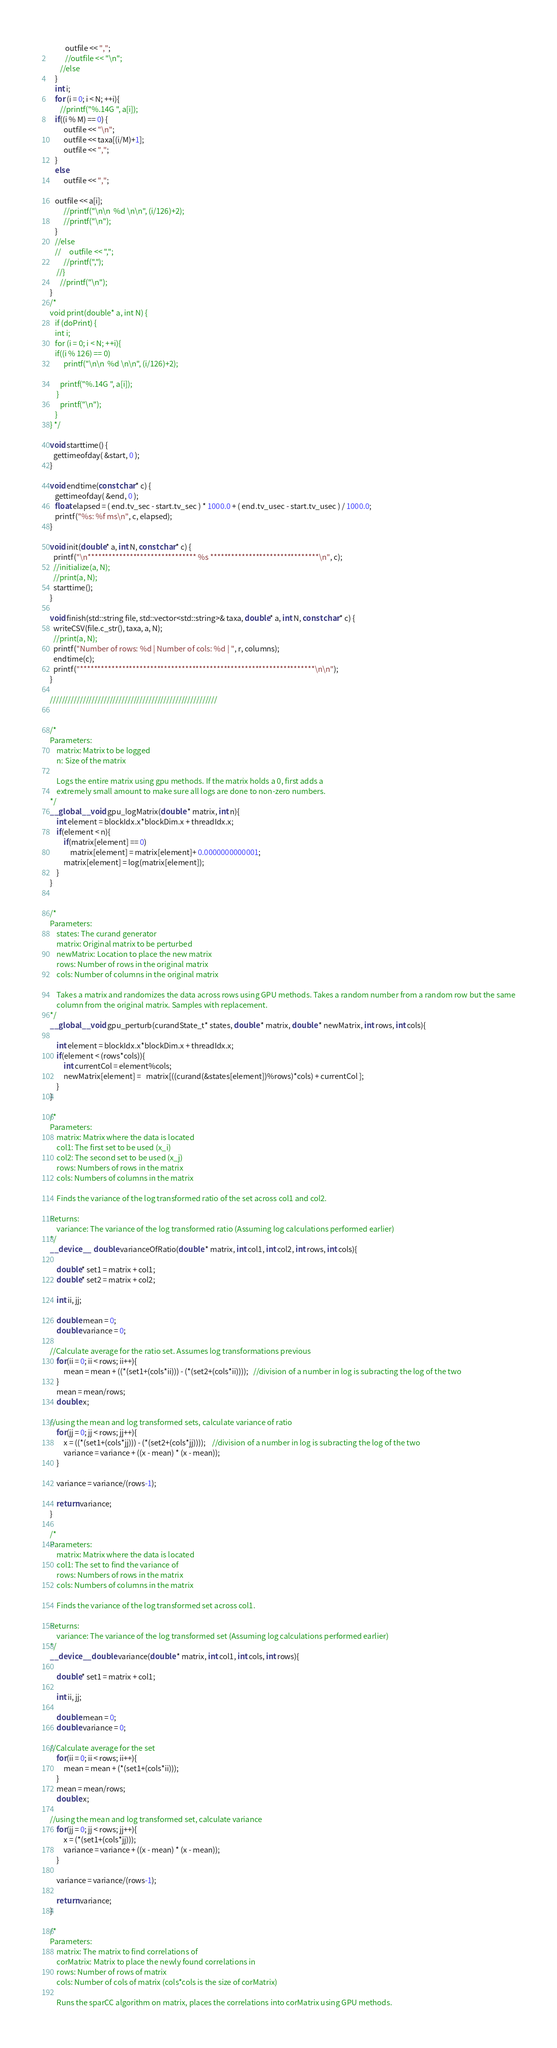<code> <loc_0><loc_0><loc_500><loc_500><_Cuda_>         outfile << ",";
         //outfile << "\n";
      //else
   }
   int i;
   for (i = 0; i < N; ++i){
      //printf("%.14G ", a[i]);
   if((i % M) == 0) {
        outfile << "\n";
        outfile << taxa[(i/M)+1];
        outfile << ",";
   }
   else
        outfile << ",";

   outfile << a[i];
        //printf("\n\n  %d \n\n", (i/126)+2);
        //printf("\n");
   }
   //else
   //     outfile << ",";
        //printf(",");
    //}
      //printf("\n");
}
/*
void print(double* a, int N) {
   if (doPrint) {
   int i;
   for (i = 0; i < N; ++i){
   if((i % 126) == 0)
        printf("\n\n  %d \n\n", (i/126)+2);
        
      printf("%.14G ", a[i]);
    }
      printf("\n");
   }
} */ 

void starttime() {
  gettimeofday( &start, 0 );
}

void endtime(const char* c) {
   gettimeofday( &end, 0 );
   float elapsed = ( end.tv_sec - start.tv_sec ) * 1000.0 + ( end.tv_usec - start.tv_usec ) / 1000.0;
   printf("%s: %f ms\n", c, elapsed); 
}

void init(double* a, int N, const char* c) {
  printf("\n******************************* %s *******************************\n", c);
  //initialize(a, N); 
  //print(a, N);
  starttime();
}

void finish(std::string file, std::vector<std::string>& taxa, double* a, int N, const char* c) {
  writeCSV(file.c_str(), taxa, a, N);
  //print(a, N);
  printf("Number of rows: %d | Number of cols: %d | ", r, columns);
  endtime(c);
  printf("*******************************************************************\n\n");
}

////////////////////////////////////////////////////////


/*
Parameters: 
    matrix: Matrix to be logged
    n: Size of the matrix
    
    Logs the entire matrix using gpu methods. If the matrix holds a 0, first adds a
    extremely small amount to make sure all logs are done to non-zero numbers.
*/
__global__ void gpu_logMatrix(double * matrix, int n){   
    int element = blockIdx.x*blockDim.x + threadIdx.x;
    if(element < n){
        if(matrix[element] == 0)
            matrix[element] = matrix[element]+ 0.0000000000001;
        matrix[element] = log(matrix[element]);    
    }
}


/*
Parameters:
    states: The curand generator
    matrix: Original matrix to be perturbed
    newMatrix: Location to place the new matrix
    rows: Number of rows in the original matrix
    cols: Number of columns in the original matrix
    
    Takes a matrix and randomizes the data across rows using GPU methods. Takes a random number from a random row but the same
    column from the original matrix. Samples with replacement.
*/
__global__ void gpu_perturb(curandState_t* states, double * matrix, double * newMatrix, int rows, int cols){
    
    int element = blockIdx.x*blockDim.x + threadIdx.x;
    if(element < (rows*cols)){        
        int currentCol = element%cols;       
        newMatrix[element] =   matrix[((curand(&states[element])%rows)*cols) + currentCol ];      
    } 
}

/*
Parameters:
    matrix: Matrix where the data is located
    col1: The first set to be used (x_i)
    col2: The second set to be used (x_j)
    rows: Numbers of rows in the matrix
    cols: Numbers of columns in the matrix
    
    Finds the variance of the log transformed ratio of the set across col1 and col2. 
    
Returns:
    variance: The variance of the log transformed ratio (Assuming log calculations performed earlier)
*/
__device__  double varianceOfRatio(double * matrix, int col1, int col2, int rows, int cols){
    
    double* set1 = matrix + col1;
    double* set2 = matrix + col2;
    
    int ii, jj;
    
    double mean = 0; 
    double variance = 0;

//Calculate average for the ratio set. Assumes log transformations previous
    for(ii = 0; ii < rows; ii++){
        mean = mean + ((*(set1+(cols*ii))) - (*(set2+(cols*ii))));   //division of a number in log is subracting the log of the two             
    }
    mean = mean/rows;
    double x;
    
//using the mean and log transformed sets, calculate variance of ratio
    for(jj = 0; jj < rows; jj++){
        x = ((*(set1+(cols*jj))) - (*(set2+(cols*jj))));    //division of a number in log is subracting the log of the two 
        variance = variance + ((x - mean) * (x - mean));                
    }
    
    variance = variance/(rows-1);
    
    return variance;
}

/*
Parameters:
    matrix: Matrix where the data is located
    col1: The set to find the variance of
    rows: Numbers of rows in the matrix
    cols: Numbers of columns in the matrix
    
    Finds the variance of the log transformed set across col1. 
    
Returns:
    variance: The variance of the log transformed set (Assuming log calculations performed earlier)
*/
__device__ double variance(double * matrix, int col1, int cols, int rows){
    
    double* set1 = matrix + col1;
    
    int ii, jj;
    
    double mean = 0; 
    double variance = 0;
    
//Calculate average for the set
    for(ii = 0; ii < rows; ii++){
        mean = mean + (*(set1+(cols*ii)));                
    }
    mean = mean/rows;
    double x;
    
//using the mean and log transformed set, calculate variance
    for(jj = 0; jj < rows; jj++){
        x = (*(set1+(cols*jj)));
        variance = variance + ((x - mean) * (x - mean));                
    }
    
    variance = variance/(rows-1);
    
    return variance;
}

/*
Parameters:
    matrix: The matrix to find correlations of
    corMatrix: Matrix to place the newly found correlations in
    rows: Number of rows of matrix
    cols: Number of cols of matrix (cols*cols is the size of corMatrix)
    
    Runs the sparCC algorithm on matrix, places the correlations into corMatrix using GPU methods. </code> 